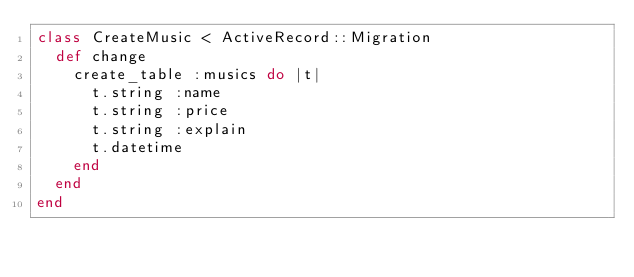Convert code to text. <code><loc_0><loc_0><loc_500><loc_500><_Ruby_>class CreateMusic < ActiveRecord::Migration
  def change
    create_table :musics do |t|
      t.string :name
      t.string :price
      t.string :explain
      t.datetime
    end
  end
end
</code> 